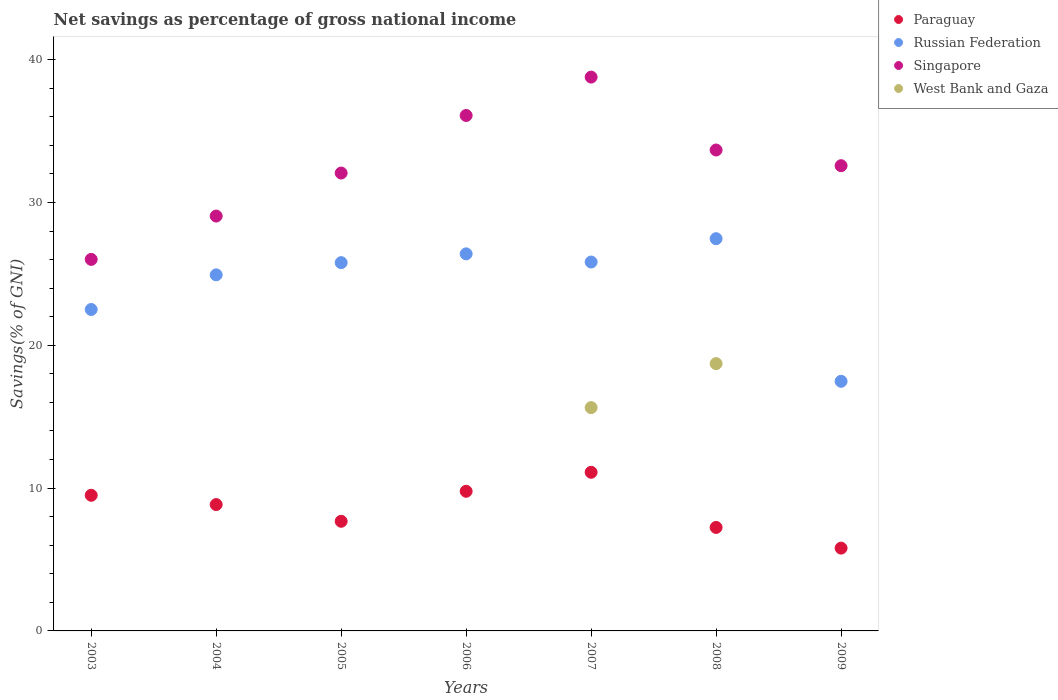Is the number of dotlines equal to the number of legend labels?
Offer a terse response. No. What is the total savings in Singapore in 2003?
Your response must be concise. 26.02. Across all years, what is the maximum total savings in Russian Federation?
Give a very brief answer. 27.47. Across all years, what is the minimum total savings in Russian Federation?
Keep it short and to the point. 17.48. In which year was the total savings in Paraguay maximum?
Provide a short and direct response. 2007. What is the total total savings in Russian Federation in the graph?
Give a very brief answer. 170.41. What is the difference between the total savings in Singapore in 2005 and that in 2006?
Your response must be concise. -4.03. What is the difference between the total savings in Singapore in 2005 and the total savings in Russian Federation in 2008?
Offer a very short reply. 4.6. What is the average total savings in Singapore per year?
Offer a very short reply. 32.61. In the year 2008, what is the difference between the total savings in Singapore and total savings in Russian Federation?
Offer a terse response. 6.21. What is the ratio of the total savings in Russian Federation in 2005 to that in 2006?
Your answer should be very brief. 0.98. Is the total savings in Russian Federation in 2005 less than that in 2009?
Give a very brief answer. No. Is the difference between the total savings in Singapore in 2003 and 2005 greater than the difference between the total savings in Russian Federation in 2003 and 2005?
Your answer should be compact. No. What is the difference between the highest and the second highest total savings in Paraguay?
Your answer should be very brief. 1.33. What is the difference between the highest and the lowest total savings in Singapore?
Your response must be concise. 12.76. Is it the case that in every year, the sum of the total savings in Paraguay and total savings in Russian Federation  is greater than the total savings in West Bank and Gaza?
Offer a terse response. Yes. Does the total savings in Paraguay monotonically increase over the years?
Give a very brief answer. No. Is the total savings in Paraguay strictly less than the total savings in Singapore over the years?
Your answer should be compact. Yes. How many dotlines are there?
Provide a short and direct response. 4. How many years are there in the graph?
Offer a very short reply. 7. Does the graph contain any zero values?
Offer a very short reply. Yes. What is the title of the graph?
Your answer should be very brief. Net savings as percentage of gross national income. What is the label or title of the X-axis?
Your answer should be compact. Years. What is the label or title of the Y-axis?
Give a very brief answer. Savings(% of GNI). What is the Savings(% of GNI) in Paraguay in 2003?
Your answer should be compact. 9.5. What is the Savings(% of GNI) in Russian Federation in 2003?
Your response must be concise. 22.51. What is the Savings(% of GNI) in Singapore in 2003?
Ensure brevity in your answer.  26.02. What is the Savings(% of GNI) in West Bank and Gaza in 2003?
Provide a short and direct response. 0. What is the Savings(% of GNI) of Paraguay in 2004?
Your response must be concise. 8.85. What is the Savings(% of GNI) of Russian Federation in 2004?
Offer a terse response. 24.93. What is the Savings(% of GNI) of Singapore in 2004?
Provide a short and direct response. 29.05. What is the Savings(% of GNI) of Paraguay in 2005?
Make the answer very short. 7.68. What is the Savings(% of GNI) in Russian Federation in 2005?
Provide a succinct answer. 25.79. What is the Savings(% of GNI) of Singapore in 2005?
Your answer should be very brief. 32.06. What is the Savings(% of GNI) in West Bank and Gaza in 2005?
Your answer should be very brief. 0. What is the Savings(% of GNI) of Paraguay in 2006?
Provide a succinct answer. 9.78. What is the Savings(% of GNI) in Russian Federation in 2006?
Make the answer very short. 26.4. What is the Savings(% of GNI) of Singapore in 2006?
Provide a short and direct response. 36.09. What is the Savings(% of GNI) of West Bank and Gaza in 2006?
Your answer should be very brief. 0. What is the Savings(% of GNI) in Paraguay in 2007?
Your answer should be compact. 11.11. What is the Savings(% of GNI) of Russian Federation in 2007?
Make the answer very short. 25.83. What is the Savings(% of GNI) in Singapore in 2007?
Your answer should be very brief. 38.78. What is the Savings(% of GNI) in West Bank and Gaza in 2007?
Your answer should be very brief. 15.64. What is the Savings(% of GNI) of Paraguay in 2008?
Keep it short and to the point. 7.25. What is the Savings(% of GNI) in Russian Federation in 2008?
Your answer should be very brief. 27.47. What is the Savings(% of GNI) in Singapore in 2008?
Your answer should be very brief. 33.68. What is the Savings(% of GNI) in West Bank and Gaza in 2008?
Give a very brief answer. 18.72. What is the Savings(% of GNI) in Paraguay in 2009?
Keep it short and to the point. 5.8. What is the Savings(% of GNI) of Russian Federation in 2009?
Offer a very short reply. 17.48. What is the Savings(% of GNI) of Singapore in 2009?
Offer a terse response. 32.58. What is the Savings(% of GNI) of West Bank and Gaza in 2009?
Ensure brevity in your answer.  0. Across all years, what is the maximum Savings(% of GNI) of Paraguay?
Offer a terse response. 11.11. Across all years, what is the maximum Savings(% of GNI) in Russian Federation?
Your answer should be compact. 27.47. Across all years, what is the maximum Savings(% of GNI) of Singapore?
Your response must be concise. 38.78. Across all years, what is the maximum Savings(% of GNI) of West Bank and Gaza?
Give a very brief answer. 18.72. Across all years, what is the minimum Savings(% of GNI) in Paraguay?
Make the answer very short. 5.8. Across all years, what is the minimum Savings(% of GNI) of Russian Federation?
Make the answer very short. 17.48. Across all years, what is the minimum Savings(% of GNI) of Singapore?
Keep it short and to the point. 26.02. Across all years, what is the minimum Savings(% of GNI) of West Bank and Gaza?
Provide a short and direct response. 0. What is the total Savings(% of GNI) of Paraguay in the graph?
Your response must be concise. 59.95. What is the total Savings(% of GNI) of Russian Federation in the graph?
Make the answer very short. 170.41. What is the total Savings(% of GNI) in Singapore in the graph?
Keep it short and to the point. 228.26. What is the total Savings(% of GNI) of West Bank and Gaza in the graph?
Offer a very short reply. 34.35. What is the difference between the Savings(% of GNI) of Paraguay in 2003 and that in 2004?
Offer a terse response. 0.65. What is the difference between the Savings(% of GNI) of Russian Federation in 2003 and that in 2004?
Your answer should be compact. -2.43. What is the difference between the Savings(% of GNI) of Singapore in 2003 and that in 2004?
Provide a succinct answer. -3.03. What is the difference between the Savings(% of GNI) of Paraguay in 2003 and that in 2005?
Make the answer very short. 1.82. What is the difference between the Savings(% of GNI) of Russian Federation in 2003 and that in 2005?
Your response must be concise. -3.28. What is the difference between the Savings(% of GNI) in Singapore in 2003 and that in 2005?
Your response must be concise. -6.05. What is the difference between the Savings(% of GNI) in Paraguay in 2003 and that in 2006?
Provide a succinct answer. -0.28. What is the difference between the Savings(% of GNI) of Russian Federation in 2003 and that in 2006?
Your answer should be compact. -3.9. What is the difference between the Savings(% of GNI) in Singapore in 2003 and that in 2006?
Your answer should be very brief. -10.08. What is the difference between the Savings(% of GNI) of Paraguay in 2003 and that in 2007?
Ensure brevity in your answer.  -1.61. What is the difference between the Savings(% of GNI) in Russian Federation in 2003 and that in 2007?
Offer a terse response. -3.32. What is the difference between the Savings(% of GNI) of Singapore in 2003 and that in 2007?
Make the answer very short. -12.76. What is the difference between the Savings(% of GNI) in Paraguay in 2003 and that in 2008?
Provide a succinct answer. 2.25. What is the difference between the Savings(% of GNI) in Russian Federation in 2003 and that in 2008?
Keep it short and to the point. -4.96. What is the difference between the Savings(% of GNI) in Singapore in 2003 and that in 2008?
Give a very brief answer. -7.66. What is the difference between the Savings(% of GNI) in Paraguay in 2003 and that in 2009?
Your answer should be very brief. 3.7. What is the difference between the Savings(% of GNI) of Russian Federation in 2003 and that in 2009?
Offer a very short reply. 5.03. What is the difference between the Savings(% of GNI) in Singapore in 2003 and that in 2009?
Offer a terse response. -6.56. What is the difference between the Savings(% of GNI) of Paraguay in 2004 and that in 2005?
Your answer should be very brief. 1.17. What is the difference between the Savings(% of GNI) of Russian Federation in 2004 and that in 2005?
Keep it short and to the point. -0.85. What is the difference between the Savings(% of GNI) in Singapore in 2004 and that in 2005?
Offer a terse response. -3.01. What is the difference between the Savings(% of GNI) of Paraguay in 2004 and that in 2006?
Make the answer very short. -0.93. What is the difference between the Savings(% of GNI) in Russian Federation in 2004 and that in 2006?
Your answer should be compact. -1.47. What is the difference between the Savings(% of GNI) in Singapore in 2004 and that in 2006?
Keep it short and to the point. -7.04. What is the difference between the Savings(% of GNI) in Paraguay in 2004 and that in 2007?
Your response must be concise. -2.26. What is the difference between the Savings(% of GNI) in Russian Federation in 2004 and that in 2007?
Make the answer very short. -0.9. What is the difference between the Savings(% of GNI) of Singapore in 2004 and that in 2007?
Offer a terse response. -9.73. What is the difference between the Savings(% of GNI) in Paraguay in 2004 and that in 2008?
Your response must be concise. 1.6. What is the difference between the Savings(% of GNI) in Russian Federation in 2004 and that in 2008?
Offer a very short reply. -2.53. What is the difference between the Savings(% of GNI) of Singapore in 2004 and that in 2008?
Ensure brevity in your answer.  -4.63. What is the difference between the Savings(% of GNI) of Paraguay in 2004 and that in 2009?
Provide a short and direct response. 3.05. What is the difference between the Savings(% of GNI) of Russian Federation in 2004 and that in 2009?
Offer a very short reply. 7.45. What is the difference between the Savings(% of GNI) in Singapore in 2004 and that in 2009?
Offer a terse response. -3.53. What is the difference between the Savings(% of GNI) of Paraguay in 2005 and that in 2006?
Your answer should be compact. -2.1. What is the difference between the Savings(% of GNI) of Russian Federation in 2005 and that in 2006?
Your answer should be very brief. -0.62. What is the difference between the Savings(% of GNI) of Singapore in 2005 and that in 2006?
Keep it short and to the point. -4.03. What is the difference between the Savings(% of GNI) in Paraguay in 2005 and that in 2007?
Your response must be concise. -3.43. What is the difference between the Savings(% of GNI) in Russian Federation in 2005 and that in 2007?
Make the answer very short. -0.04. What is the difference between the Savings(% of GNI) in Singapore in 2005 and that in 2007?
Provide a succinct answer. -6.72. What is the difference between the Savings(% of GNI) of Paraguay in 2005 and that in 2008?
Offer a terse response. 0.43. What is the difference between the Savings(% of GNI) of Russian Federation in 2005 and that in 2008?
Keep it short and to the point. -1.68. What is the difference between the Savings(% of GNI) in Singapore in 2005 and that in 2008?
Provide a short and direct response. -1.61. What is the difference between the Savings(% of GNI) in Paraguay in 2005 and that in 2009?
Provide a succinct answer. 1.88. What is the difference between the Savings(% of GNI) of Russian Federation in 2005 and that in 2009?
Your response must be concise. 8.31. What is the difference between the Savings(% of GNI) in Singapore in 2005 and that in 2009?
Keep it short and to the point. -0.51. What is the difference between the Savings(% of GNI) in Paraguay in 2006 and that in 2007?
Give a very brief answer. -1.33. What is the difference between the Savings(% of GNI) of Russian Federation in 2006 and that in 2007?
Your answer should be compact. 0.57. What is the difference between the Savings(% of GNI) of Singapore in 2006 and that in 2007?
Your answer should be compact. -2.69. What is the difference between the Savings(% of GNI) in Paraguay in 2006 and that in 2008?
Give a very brief answer. 2.53. What is the difference between the Savings(% of GNI) in Russian Federation in 2006 and that in 2008?
Your answer should be very brief. -1.06. What is the difference between the Savings(% of GNI) of Singapore in 2006 and that in 2008?
Keep it short and to the point. 2.42. What is the difference between the Savings(% of GNI) of Paraguay in 2006 and that in 2009?
Make the answer very short. 3.98. What is the difference between the Savings(% of GNI) in Russian Federation in 2006 and that in 2009?
Provide a short and direct response. 8.92. What is the difference between the Savings(% of GNI) of Singapore in 2006 and that in 2009?
Provide a short and direct response. 3.52. What is the difference between the Savings(% of GNI) of Paraguay in 2007 and that in 2008?
Your response must be concise. 3.86. What is the difference between the Savings(% of GNI) in Russian Federation in 2007 and that in 2008?
Make the answer very short. -1.63. What is the difference between the Savings(% of GNI) of Singapore in 2007 and that in 2008?
Offer a terse response. 5.11. What is the difference between the Savings(% of GNI) of West Bank and Gaza in 2007 and that in 2008?
Provide a short and direct response. -3.08. What is the difference between the Savings(% of GNI) in Paraguay in 2007 and that in 2009?
Give a very brief answer. 5.31. What is the difference between the Savings(% of GNI) in Russian Federation in 2007 and that in 2009?
Keep it short and to the point. 8.35. What is the difference between the Savings(% of GNI) of Singapore in 2007 and that in 2009?
Offer a terse response. 6.2. What is the difference between the Savings(% of GNI) in Paraguay in 2008 and that in 2009?
Offer a terse response. 1.45. What is the difference between the Savings(% of GNI) in Russian Federation in 2008 and that in 2009?
Give a very brief answer. 9.99. What is the difference between the Savings(% of GNI) in Singapore in 2008 and that in 2009?
Keep it short and to the point. 1.1. What is the difference between the Savings(% of GNI) of Paraguay in 2003 and the Savings(% of GNI) of Russian Federation in 2004?
Offer a very short reply. -15.44. What is the difference between the Savings(% of GNI) of Paraguay in 2003 and the Savings(% of GNI) of Singapore in 2004?
Offer a terse response. -19.55. What is the difference between the Savings(% of GNI) in Russian Federation in 2003 and the Savings(% of GNI) in Singapore in 2004?
Provide a short and direct response. -6.54. What is the difference between the Savings(% of GNI) in Paraguay in 2003 and the Savings(% of GNI) in Russian Federation in 2005?
Provide a succinct answer. -16.29. What is the difference between the Savings(% of GNI) of Paraguay in 2003 and the Savings(% of GNI) of Singapore in 2005?
Provide a succinct answer. -22.57. What is the difference between the Savings(% of GNI) in Russian Federation in 2003 and the Savings(% of GNI) in Singapore in 2005?
Your answer should be very brief. -9.55. What is the difference between the Savings(% of GNI) in Paraguay in 2003 and the Savings(% of GNI) in Russian Federation in 2006?
Make the answer very short. -16.91. What is the difference between the Savings(% of GNI) of Paraguay in 2003 and the Savings(% of GNI) of Singapore in 2006?
Your response must be concise. -26.6. What is the difference between the Savings(% of GNI) in Russian Federation in 2003 and the Savings(% of GNI) in Singapore in 2006?
Make the answer very short. -13.59. What is the difference between the Savings(% of GNI) in Paraguay in 2003 and the Savings(% of GNI) in Russian Federation in 2007?
Keep it short and to the point. -16.33. What is the difference between the Savings(% of GNI) of Paraguay in 2003 and the Savings(% of GNI) of Singapore in 2007?
Ensure brevity in your answer.  -29.28. What is the difference between the Savings(% of GNI) of Paraguay in 2003 and the Savings(% of GNI) of West Bank and Gaza in 2007?
Make the answer very short. -6.14. What is the difference between the Savings(% of GNI) in Russian Federation in 2003 and the Savings(% of GNI) in Singapore in 2007?
Keep it short and to the point. -16.27. What is the difference between the Savings(% of GNI) of Russian Federation in 2003 and the Savings(% of GNI) of West Bank and Gaza in 2007?
Offer a terse response. 6.87. What is the difference between the Savings(% of GNI) in Singapore in 2003 and the Savings(% of GNI) in West Bank and Gaza in 2007?
Give a very brief answer. 10.38. What is the difference between the Savings(% of GNI) in Paraguay in 2003 and the Savings(% of GNI) in Russian Federation in 2008?
Provide a short and direct response. -17.97. What is the difference between the Savings(% of GNI) in Paraguay in 2003 and the Savings(% of GNI) in Singapore in 2008?
Give a very brief answer. -24.18. What is the difference between the Savings(% of GNI) of Paraguay in 2003 and the Savings(% of GNI) of West Bank and Gaza in 2008?
Your answer should be very brief. -9.22. What is the difference between the Savings(% of GNI) in Russian Federation in 2003 and the Savings(% of GNI) in Singapore in 2008?
Keep it short and to the point. -11.17. What is the difference between the Savings(% of GNI) of Russian Federation in 2003 and the Savings(% of GNI) of West Bank and Gaza in 2008?
Your answer should be compact. 3.79. What is the difference between the Savings(% of GNI) in Singapore in 2003 and the Savings(% of GNI) in West Bank and Gaza in 2008?
Provide a succinct answer. 7.3. What is the difference between the Savings(% of GNI) of Paraguay in 2003 and the Savings(% of GNI) of Russian Federation in 2009?
Make the answer very short. -7.98. What is the difference between the Savings(% of GNI) of Paraguay in 2003 and the Savings(% of GNI) of Singapore in 2009?
Your answer should be very brief. -23.08. What is the difference between the Savings(% of GNI) in Russian Federation in 2003 and the Savings(% of GNI) in Singapore in 2009?
Keep it short and to the point. -10.07. What is the difference between the Savings(% of GNI) in Paraguay in 2004 and the Savings(% of GNI) in Russian Federation in 2005?
Your answer should be compact. -16.94. What is the difference between the Savings(% of GNI) in Paraguay in 2004 and the Savings(% of GNI) in Singapore in 2005?
Offer a very short reply. -23.22. What is the difference between the Savings(% of GNI) in Russian Federation in 2004 and the Savings(% of GNI) in Singapore in 2005?
Offer a very short reply. -7.13. What is the difference between the Savings(% of GNI) of Paraguay in 2004 and the Savings(% of GNI) of Russian Federation in 2006?
Offer a terse response. -17.56. What is the difference between the Savings(% of GNI) of Paraguay in 2004 and the Savings(% of GNI) of Singapore in 2006?
Your answer should be very brief. -27.25. What is the difference between the Savings(% of GNI) of Russian Federation in 2004 and the Savings(% of GNI) of Singapore in 2006?
Your answer should be very brief. -11.16. What is the difference between the Savings(% of GNI) of Paraguay in 2004 and the Savings(% of GNI) of Russian Federation in 2007?
Offer a very short reply. -16.98. What is the difference between the Savings(% of GNI) in Paraguay in 2004 and the Savings(% of GNI) in Singapore in 2007?
Keep it short and to the point. -29.93. What is the difference between the Savings(% of GNI) of Paraguay in 2004 and the Savings(% of GNI) of West Bank and Gaza in 2007?
Give a very brief answer. -6.79. What is the difference between the Savings(% of GNI) of Russian Federation in 2004 and the Savings(% of GNI) of Singapore in 2007?
Your response must be concise. -13.85. What is the difference between the Savings(% of GNI) in Russian Federation in 2004 and the Savings(% of GNI) in West Bank and Gaza in 2007?
Make the answer very short. 9.3. What is the difference between the Savings(% of GNI) of Singapore in 2004 and the Savings(% of GNI) of West Bank and Gaza in 2007?
Your answer should be compact. 13.41. What is the difference between the Savings(% of GNI) of Paraguay in 2004 and the Savings(% of GNI) of Russian Federation in 2008?
Your answer should be very brief. -18.62. What is the difference between the Savings(% of GNI) in Paraguay in 2004 and the Savings(% of GNI) in Singapore in 2008?
Offer a terse response. -24.83. What is the difference between the Savings(% of GNI) in Paraguay in 2004 and the Savings(% of GNI) in West Bank and Gaza in 2008?
Your answer should be very brief. -9.87. What is the difference between the Savings(% of GNI) in Russian Federation in 2004 and the Savings(% of GNI) in Singapore in 2008?
Make the answer very short. -8.74. What is the difference between the Savings(% of GNI) of Russian Federation in 2004 and the Savings(% of GNI) of West Bank and Gaza in 2008?
Provide a short and direct response. 6.22. What is the difference between the Savings(% of GNI) of Singapore in 2004 and the Savings(% of GNI) of West Bank and Gaza in 2008?
Your answer should be compact. 10.33. What is the difference between the Savings(% of GNI) of Paraguay in 2004 and the Savings(% of GNI) of Russian Federation in 2009?
Make the answer very short. -8.63. What is the difference between the Savings(% of GNI) in Paraguay in 2004 and the Savings(% of GNI) in Singapore in 2009?
Provide a succinct answer. -23.73. What is the difference between the Savings(% of GNI) in Russian Federation in 2004 and the Savings(% of GNI) in Singapore in 2009?
Offer a terse response. -7.64. What is the difference between the Savings(% of GNI) in Paraguay in 2005 and the Savings(% of GNI) in Russian Federation in 2006?
Your response must be concise. -18.73. What is the difference between the Savings(% of GNI) of Paraguay in 2005 and the Savings(% of GNI) of Singapore in 2006?
Offer a very short reply. -28.42. What is the difference between the Savings(% of GNI) in Russian Federation in 2005 and the Savings(% of GNI) in Singapore in 2006?
Keep it short and to the point. -10.31. What is the difference between the Savings(% of GNI) in Paraguay in 2005 and the Savings(% of GNI) in Russian Federation in 2007?
Offer a very short reply. -18.16. What is the difference between the Savings(% of GNI) of Paraguay in 2005 and the Savings(% of GNI) of Singapore in 2007?
Your answer should be compact. -31.1. What is the difference between the Savings(% of GNI) in Paraguay in 2005 and the Savings(% of GNI) in West Bank and Gaza in 2007?
Keep it short and to the point. -7.96. What is the difference between the Savings(% of GNI) of Russian Federation in 2005 and the Savings(% of GNI) of Singapore in 2007?
Your answer should be very brief. -12.99. What is the difference between the Savings(% of GNI) in Russian Federation in 2005 and the Savings(% of GNI) in West Bank and Gaza in 2007?
Keep it short and to the point. 10.15. What is the difference between the Savings(% of GNI) of Singapore in 2005 and the Savings(% of GNI) of West Bank and Gaza in 2007?
Provide a succinct answer. 16.43. What is the difference between the Savings(% of GNI) in Paraguay in 2005 and the Savings(% of GNI) in Russian Federation in 2008?
Offer a very short reply. -19.79. What is the difference between the Savings(% of GNI) of Paraguay in 2005 and the Savings(% of GNI) of Singapore in 2008?
Your answer should be very brief. -26. What is the difference between the Savings(% of GNI) in Paraguay in 2005 and the Savings(% of GNI) in West Bank and Gaza in 2008?
Ensure brevity in your answer.  -11.04. What is the difference between the Savings(% of GNI) in Russian Federation in 2005 and the Savings(% of GNI) in Singapore in 2008?
Give a very brief answer. -7.89. What is the difference between the Savings(% of GNI) of Russian Federation in 2005 and the Savings(% of GNI) of West Bank and Gaza in 2008?
Give a very brief answer. 7.07. What is the difference between the Savings(% of GNI) of Singapore in 2005 and the Savings(% of GNI) of West Bank and Gaza in 2008?
Offer a very short reply. 13.35. What is the difference between the Savings(% of GNI) of Paraguay in 2005 and the Savings(% of GNI) of Russian Federation in 2009?
Make the answer very short. -9.8. What is the difference between the Savings(% of GNI) in Paraguay in 2005 and the Savings(% of GNI) in Singapore in 2009?
Provide a short and direct response. -24.9. What is the difference between the Savings(% of GNI) of Russian Federation in 2005 and the Savings(% of GNI) of Singapore in 2009?
Provide a succinct answer. -6.79. What is the difference between the Savings(% of GNI) in Paraguay in 2006 and the Savings(% of GNI) in Russian Federation in 2007?
Give a very brief answer. -16.05. What is the difference between the Savings(% of GNI) of Paraguay in 2006 and the Savings(% of GNI) of Singapore in 2007?
Your response must be concise. -29. What is the difference between the Savings(% of GNI) in Paraguay in 2006 and the Savings(% of GNI) in West Bank and Gaza in 2007?
Ensure brevity in your answer.  -5.86. What is the difference between the Savings(% of GNI) of Russian Federation in 2006 and the Savings(% of GNI) of Singapore in 2007?
Your answer should be very brief. -12.38. What is the difference between the Savings(% of GNI) of Russian Federation in 2006 and the Savings(% of GNI) of West Bank and Gaza in 2007?
Ensure brevity in your answer.  10.77. What is the difference between the Savings(% of GNI) in Singapore in 2006 and the Savings(% of GNI) in West Bank and Gaza in 2007?
Your answer should be very brief. 20.46. What is the difference between the Savings(% of GNI) of Paraguay in 2006 and the Savings(% of GNI) of Russian Federation in 2008?
Make the answer very short. -17.69. What is the difference between the Savings(% of GNI) in Paraguay in 2006 and the Savings(% of GNI) in Singapore in 2008?
Give a very brief answer. -23.9. What is the difference between the Savings(% of GNI) in Paraguay in 2006 and the Savings(% of GNI) in West Bank and Gaza in 2008?
Offer a very short reply. -8.94. What is the difference between the Savings(% of GNI) of Russian Federation in 2006 and the Savings(% of GNI) of Singapore in 2008?
Offer a terse response. -7.27. What is the difference between the Savings(% of GNI) of Russian Federation in 2006 and the Savings(% of GNI) of West Bank and Gaza in 2008?
Give a very brief answer. 7.69. What is the difference between the Savings(% of GNI) in Singapore in 2006 and the Savings(% of GNI) in West Bank and Gaza in 2008?
Ensure brevity in your answer.  17.38. What is the difference between the Savings(% of GNI) of Paraguay in 2006 and the Savings(% of GNI) of Russian Federation in 2009?
Provide a short and direct response. -7.7. What is the difference between the Savings(% of GNI) in Paraguay in 2006 and the Savings(% of GNI) in Singapore in 2009?
Keep it short and to the point. -22.8. What is the difference between the Savings(% of GNI) in Russian Federation in 2006 and the Savings(% of GNI) in Singapore in 2009?
Your response must be concise. -6.17. What is the difference between the Savings(% of GNI) of Paraguay in 2007 and the Savings(% of GNI) of Russian Federation in 2008?
Offer a terse response. -16.36. What is the difference between the Savings(% of GNI) of Paraguay in 2007 and the Savings(% of GNI) of Singapore in 2008?
Your answer should be very brief. -22.57. What is the difference between the Savings(% of GNI) in Paraguay in 2007 and the Savings(% of GNI) in West Bank and Gaza in 2008?
Give a very brief answer. -7.61. What is the difference between the Savings(% of GNI) in Russian Federation in 2007 and the Savings(% of GNI) in Singapore in 2008?
Offer a terse response. -7.84. What is the difference between the Savings(% of GNI) of Russian Federation in 2007 and the Savings(% of GNI) of West Bank and Gaza in 2008?
Provide a succinct answer. 7.12. What is the difference between the Savings(% of GNI) of Singapore in 2007 and the Savings(% of GNI) of West Bank and Gaza in 2008?
Provide a succinct answer. 20.06. What is the difference between the Savings(% of GNI) in Paraguay in 2007 and the Savings(% of GNI) in Russian Federation in 2009?
Give a very brief answer. -6.37. What is the difference between the Savings(% of GNI) of Paraguay in 2007 and the Savings(% of GNI) of Singapore in 2009?
Keep it short and to the point. -21.47. What is the difference between the Savings(% of GNI) in Russian Federation in 2007 and the Savings(% of GNI) in Singapore in 2009?
Offer a very short reply. -6.75. What is the difference between the Savings(% of GNI) in Paraguay in 2008 and the Savings(% of GNI) in Russian Federation in 2009?
Offer a very short reply. -10.23. What is the difference between the Savings(% of GNI) in Paraguay in 2008 and the Savings(% of GNI) in Singapore in 2009?
Your response must be concise. -25.33. What is the difference between the Savings(% of GNI) in Russian Federation in 2008 and the Savings(% of GNI) in Singapore in 2009?
Provide a short and direct response. -5.11. What is the average Savings(% of GNI) in Paraguay per year?
Your answer should be compact. 8.56. What is the average Savings(% of GNI) in Russian Federation per year?
Offer a terse response. 24.34. What is the average Savings(% of GNI) of Singapore per year?
Your response must be concise. 32.61. What is the average Savings(% of GNI) in West Bank and Gaza per year?
Keep it short and to the point. 4.91. In the year 2003, what is the difference between the Savings(% of GNI) in Paraguay and Savings(% of GNI) in Russian Federation?
Offer a terse response. -13.01. In the year 2003, what is the difference between the Savings(% of GNI) in Paraguay and Savings(% of GNI) in Singapore?
Offer a terse response. -16.52. In the year 2003, what is the difference between the Savings(% of GNI) of Russian Federation and Savings(% of GNI) of Singapore?
Give a very brief answer. -3.51. In the year 2004, what is the difference between the Savings(% of GNI) of Paraguay and Savings(% of GNI) of Russian Federation?
Ensure brevity in your answer.  -16.09. In the year 2004, what is the difference between the Savings(% of GNI) in Paraguay and Savings(% of GNI) in Singapore?
Your answer should be compact. -20.2. In the year 2004, what is the difference between the Savings(% of GNI) in Russian Federation and Savings(% of GNI) in Singapore?
Provide a short and direct response. -4.12. In the year 2005, what is the difference between the Savings(% of GNI) of Paraguay and Savings(% of GNI) of Russian Federation?
Provide a succinct answer. -18.11. In the year 2005, what is the difference between the Savings(% of GNI) of Paraguay and Savings(% of GNI) of Singapore?
Your answer should be very brief. -24.39. In the year 2005, what is the difference between the Savings(% of GNI) in Russian Federation and Savings(% of GNI) in Singapore?
Ensure brevity in your answer.  -6.27. In the year 2006, what is the difference between the Savings(% of GNI) in Paraguay and Savings(% of GNI) in Russian Federation?
Ensure brevity in your answer.  -16.63. In the year 2006, what is the difference between the Savings(% of GNI) in Paraguay and Savings(% of GNI) in Singapore?
Your answer should be compact. -26.32. In the year 2006, what is the difference between the Savings(% of GNI) in Russian Federation and Savings(% of GNI) in Singapore?
Keep it short and to the point. -9.69. In the year 2007, what is the difference between the Savings(% of GNI) in Paraguay and Savings(% of GNI) in Russian Federation?
Provide a succinct answer. -14.72. In the year 2007, what is the difference between the Savings(% of GNI) in Paraguay and Savings(% of GNI) in Singapore?
Offer a terse response. -27.67. In the year 2007, what is the difference between the Savings(% of GNI) of Paraguay and Savings(% of GNI) of West Bank and Gaza?
Provide a succinct answer. -4.53. In the year 2007, what is the difference between the Savings(% of GNI) in Russian Federation and Savings(% of GNI) in Singapore?
Offer a terse response. -12.95. In the year 2007, what is the difference between the Savings(% of GNI) of Russian Federation and Savings(% of GNI) of West Bank and Gaza?
Your response must be concise. 10.19. In the year 2007, what is the difference between the Savings(% of GNI) of Singapore and Savings(% of GNI) of West Bank and Gaza?
Your response must be concise. 23.14. In the year 2008, what is the difference between the Savings(% of GNI) in Paraguay and Savings(% of GNI) in Russian Federation?
Give a very brief answer. -20.22. In the year 2008, what is the difference between the Savings(% of GNI) in Paraguay and Savings(% of GNI) in Singapore?
Give a very brief answer. -26.43. In the year 2008, what is the difference between the Savings(% of GNI) of Paraguay and Savings(% of GNI) of West Bank and Gaza?
Ensure brevity in your answer.  -11.47. In the year 2008, what is the difference between the Savings(% of GNI) in Russian Federation and Savings(% of GNI) in Singapore?
Provide a short and direct response. -6.21. In the year 2008, what is the difference between the Savings(% of GNI) of Russian Federation and Savings(% of GNI) of West Bank and Gaza?
Provide a succinct answer. 8.75. In the year 2008, what is the difference between the Savings(% of GNI) of Singapore and Savings(% of GNI) of West Bank and Gaza?
Ensure brevity in your answer.  14.96. In the year 2009, what is the difference between the Savings(% of GNI) of Paraguay and Savings(% of GNI) of Russian Federation?
Provide a succinct answer. -11.68. In the year 2009, what is the difference between the Savings(% of GNI) in Paraguay and Savings(% of GNI) in Singapore?
Keep it short and to the point. -26.78. In the year 2009, what is the difference between the Savings(% of GNI) in Russian Federation and Savings(% of GNI) in Singapore?
Keep it short and to the point. -15.1. What is the ratio of the Savings(% of GNI) in Paraguay in 2003 to that in 2004?
Your answer should be very brief. 1.07. What is the ratio of the Savings(% of GNI) in Russian Federation in 2003 to that in 2004?
Provide a succinct answer. 0.9. What is the ratio of the Savings(% of GNI) of Singapore in 2003 to that in 2004?
Offer a terse response. 0.9. What is the ratio of the Savings(% of GNI) in Paraguay in 2003 to that in 2005?
Give a very brief answer. 1.24. What is the ratio of the Savings(% of GNI) in Russian Federation in 2003 to that in 2005?
Give a very brief answer. 0.87. What is the ratio of the Savings(% of GNI) of Singapore in 2003 to that in 2005?
Ensure brevity in your answer.  0.81. What is the ratio of the Savings(% of GNI) in Paraguay in 2003 to that in 2006?
Provide a succinct answer. 0.97. What is the ratio of the Savings(% of GNI) of Russian Federation in 2003 to that in 2006?
Provide a short and direct response. 0.85. What is the ratio of the Savings(% of GNI) in Singapore in 2003 to that in 2006?
Offer a very short reply. 0.72. What is the ratio of the Savings(% of GNI) of Paraguay in 2003 to that in 2007?
Your answer should be compact. 0.85. What is the ratio of the Savings(% of GNI) of Russian Federation in 2003 to that in 2007?
Offer a very short reply. 0.87. What is the ratio of the Savings(% of GNI) in Singapore in 2003 to that in 2007?
Ensure brevity in your answer.  0.67. What is the ratio of the Savings(% of GNI) of Paraguay in 2003 to that in 2008?
Your response must be concise. 1.31. What is the ratio of the Savings(% of GNI) of Russian Federation in 2003 to that in 2008?
Offer a very short reply. 0.82. What is the ratio of the Savings(% of GNI) in Singapore in 2003 to that in 2008?
Offer a very short reply. 0.77. What is the ratio of the Savings(% of GNI) of Paraguay in 2003 to that in 2009?
Your response must be concise. 1.64. What is the ratio of the Savings(% of GNI) of Russian Federation in 2003 to that in 2009?
Offer a very short reply. 1.29. What is the ratio of the Savings(% of GNI) in Singapore in 2003 to that in 2009?
Provide a succinct answer. 0.8. What is the ratio of the Savings(% of GNI) of Paraguay in 2004 to that in 2005?
Ensure brevity in your answer.  1.15. What is the ratio of the Savings(% of GNI) of Russian Federation in 2004 to that in 2005?
Your answer should be compact. 0.97. What is the ratio of the Savings(% of GNI) of Singapore in 2004 to that in 2005?
Your answer should be compact. 0.91. What is the ratio of the Savings(% of GNI) in Paraguay in 2004 to that in 2006?
Your response must be concise. 0.9. What is the ratio of the Savings(% of GNI) of Russian Federation in 2004 to that in 2006?
Keep it short and to the point. 0.94. What is the ratio of the Savings(% of GNI) of Singapore in 2004 to that in 2006?
Your answer should be compact. 0.8. What is the ratio of the Savings(% of GNI) in Paraguay in 2004 to that in 2007?
Your answer should be compact. 0.8. What is the ratio of the Savings(% of GNI) in Russian Federation in 2004 to that in 2007?
Provide a succinct answer. 0.97. What is the ratio of the Savings(% of GNI) of Singapore in 2004 to that in 2007?
Offer a terse response. 0.75. What is the ratio of the Savings(% of GNI) in Paraguay in 2004 to that in 2008?
Your answer should be compact. 1.22. What is the ratio of the Savings(% of GNI) in Russian Federation in 2004 to that in 2008?
Offer a terse response. 0.91. What is the ratio of the Savings(% of GNI) in Singapore in 2004 to that in 2008?
Provide a succinct answer. 0.86. What is the ratio of the Savings(% of GNI) in Paraguay in 2004 to that in 2009?
Your answer should be compact. 1.53. What is the ratio of the Savings(% of GNI) in Russian Federation in 2004 to that in 2009?
Keep it short and to the point. 1.43. What is the ratio of the Savings(% of GNI) of Singapore in 2004 to that in 2009?
Offer a terse response. 0.89. What is the ratio of the Savings(% of GNI) of Paraguay in 2005 to that in 2006?
Offer a terse response. 0.79. What is the ratio of the Savings(% of GNI) in Russian Federation in 2005 to that in 2006?
Keep it short and to the point. 0.98. What is the ratio of the Savings(% of GNI) of Singapore in 2005 to that in 2006?
Offer a terse response. 0.89. What is the ratio of the Savings(% of GNI) in Paraguay in 2005 to that in 2007?
Keep it short and to the point. 0.69. What is the ratio of the Savings(% of GNI) in Russian Federation in 2005 to that in 2007?
Your answer should be compact. 1. What is the ratio of the Savings(% of GNI) of Singapore in 2005 to that in 2007?
Offer a very short reply. 0.83. What is the ratio of the Savings(% of GNI) in Paraguay in 2005 to that in 2008?
Ensure brevity in your answer.  1.06. What is the ratio of the Savings(% of GNI) of Russian Federation in 2005 to that in 2008?
Provide a short and direct response. 0.94. What is the ratio of the Savings(% of GNI) in Singapore in 2005 to that in 2008?
Your answer should be very brief. 0.95. What is the ratio of the Savings(% of GNI) of Paraguay in 2005 to that in 2009?
Your answer should be compact. 1.32. What is the ratio of the Savings(% of GNI) in Russian Federation in 2005 to that in 2009?
Keep it short and to the point. 1.48. What is the ratio of the Savings(% of GNI) in Singapore in 2005 to that in 2009?
Provide a succinct answer. 0.98. What is the ratio of the Savings(% of GNI) in Paraguay in 2006 to that in 2007?
Ensure brevity in your answer.  0.88. What is the ratio of the Savings(% of GNI) in Russian Federation in 2006 to that in 2007?
Offer a very short reply. 1.02. What is the ratio of the Savings(% of GNI) in Singapore in 2006 to that in 2007?
Your answer should be very brief. 0.93. What is the ratio of the Savings(% of GNI) in Paraguay in 2006 to that in 2008?
Provide a short and direct response. 1.35. What is the ratio of the Savings(% of GNI) of Russian Federation in 2006 to that in 2008?
Make the answer very short. 0.96. What is the ratio of the Savings(% of GNI) in Singapore in 2006 to that in 2008?
Give a very brief answer. 1.07. What is the ratio of the Savings(% of GNI) of Paraguay in 2006 to that in 2009?
Give a very brief answer. 1.69. What is the ratio of the Savings(% of GNI) of Russian Federation in 2006 to that in 2009?
Your answer should be very brief. 1.51. What is the ratio of the Savings(% of GNI) of Singapore in 2006 to that in 2009?
Provide a short and direct response. 1.11. What is the ratio of the Savings(% of GNI) in Paraguay in 2007 to that in 2008?
Your response must be concise. 1.53. What is the ratio of the Savings(% of GNI) in Russian Federation in 2007 to that in 2008?
Your answer should be very brief. 0.94. What is the ratio of the Savings(% of GNI) of Singapore in 2007 to that in 2008?
Your answer should be very brief. 1.15. What is the ratio of the Savings(% of GNI) in West Bank and Gaza in 2007 to that in 2008?
Provide a succinct answer. 0.84. What is the ratio of the Savings(% of GNI) of Paraguay in 2007 to that in 2009?
Give a very brief answer. 1.92. What is the ratio of the Savings(% of GNI) in Russian Federation in 2007 to that in 2009?
Keep it short and to the point. 1.48. What is the ratio of the Savings(% of GNI) in Singapore in 2007 to that in 2009?
Your answer should be very brief. 1.19. What is the ratio of the Savings(% of GNI) of Paraguay in 2008 to that in 2009?
Give a very brief answer. 1.25. What is the ratio of the Savings(% of GNI) of Russian Federation in 2008 to that in 2009?
Keep it short and to the point. 1.57. What is the ratio of the Savings(% of GNI) in Singapore in 2008 to that in 2009?
Provide a succinct answer. 1.03. What is the difference between the highest and the second highest Savings(% of GNI) of Paraguay?
Provide a short and direct response. 1.33. What is the difference between the highest and the second highest Savings(% of GNI) of Russian Federation?
Keep it short and to the point. 1.06. What is the difference between the highest and the second highest Savings(% of GNI) in Singapore?
Offer a very short reply. 2.69. What is the difference between the highest and the lowest Savings(% of GNI) of Paraguay?
Offer a terse response. 5.31. What is the difference between the highest and the lowest Savings(% of GNI) of Russian Federation?
Ensure brevity in your answer.  9.99. What is the difference between the highest and the lowest Savings(% of GNI) of Singapore?
Offer a terse response. 12.76. What is the difference between the highest and the lowest Savings(% of GNI) in West Bank and Gaza?
Your response must be concise. 18.72. 